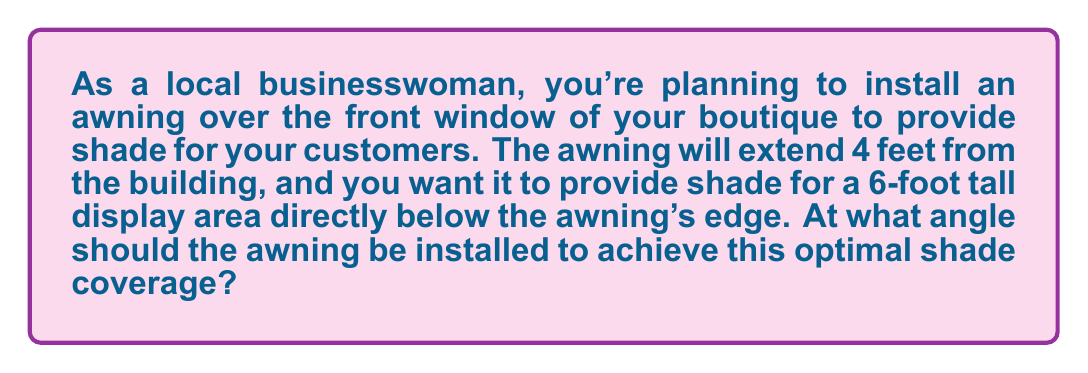What is the answer to this math problem? Let's approach this step-by-step:

1) First, let's visualize the problem:

[asy]
unitsize(20);
draw((0,0)--(4,0)--(4,6)--(0,6)--cycle);
draw((0,6)--(4,0),dashed);
label("6 ft", (4.5,3), E);
label("4 ft", (2,-0.5), S);
label("$\theta$", (0.5,5.5), NW);
dot((0,6));
dot((4,0));
[/asy]

2) We can see that this forms a right triangle, where:
   - The awning is the hypotenuse
   - The height of the display area (6 feet) is the opposite side
   - The extension of the awning (4 feet) is the adjacent side

3) We need to find the angle $\theta$ between the awning and the horizontal.

4) In this right triangle, we know the opposite and adjacent sides, so we can use the tangent function:

   $$\tan(\theta) = \frac{\text{opposite}}{\text{adjacent}} = \frac{6}{4} = 1.5$$

5) To find $\theta$, we need to use the inverse tangent (arctan or $\tan^{-1}$):

   $$\theta = \tan^{-1}(1.5)$$

6) Using a calculator or trigonometric tables:

   $$\theta \approx 56.31^\circ$$

7) This angle should be rounded to a practical measurement for installation, so we can say approximately 56°.
Answer: The optimal angle for the store awning is approximately 56°. 